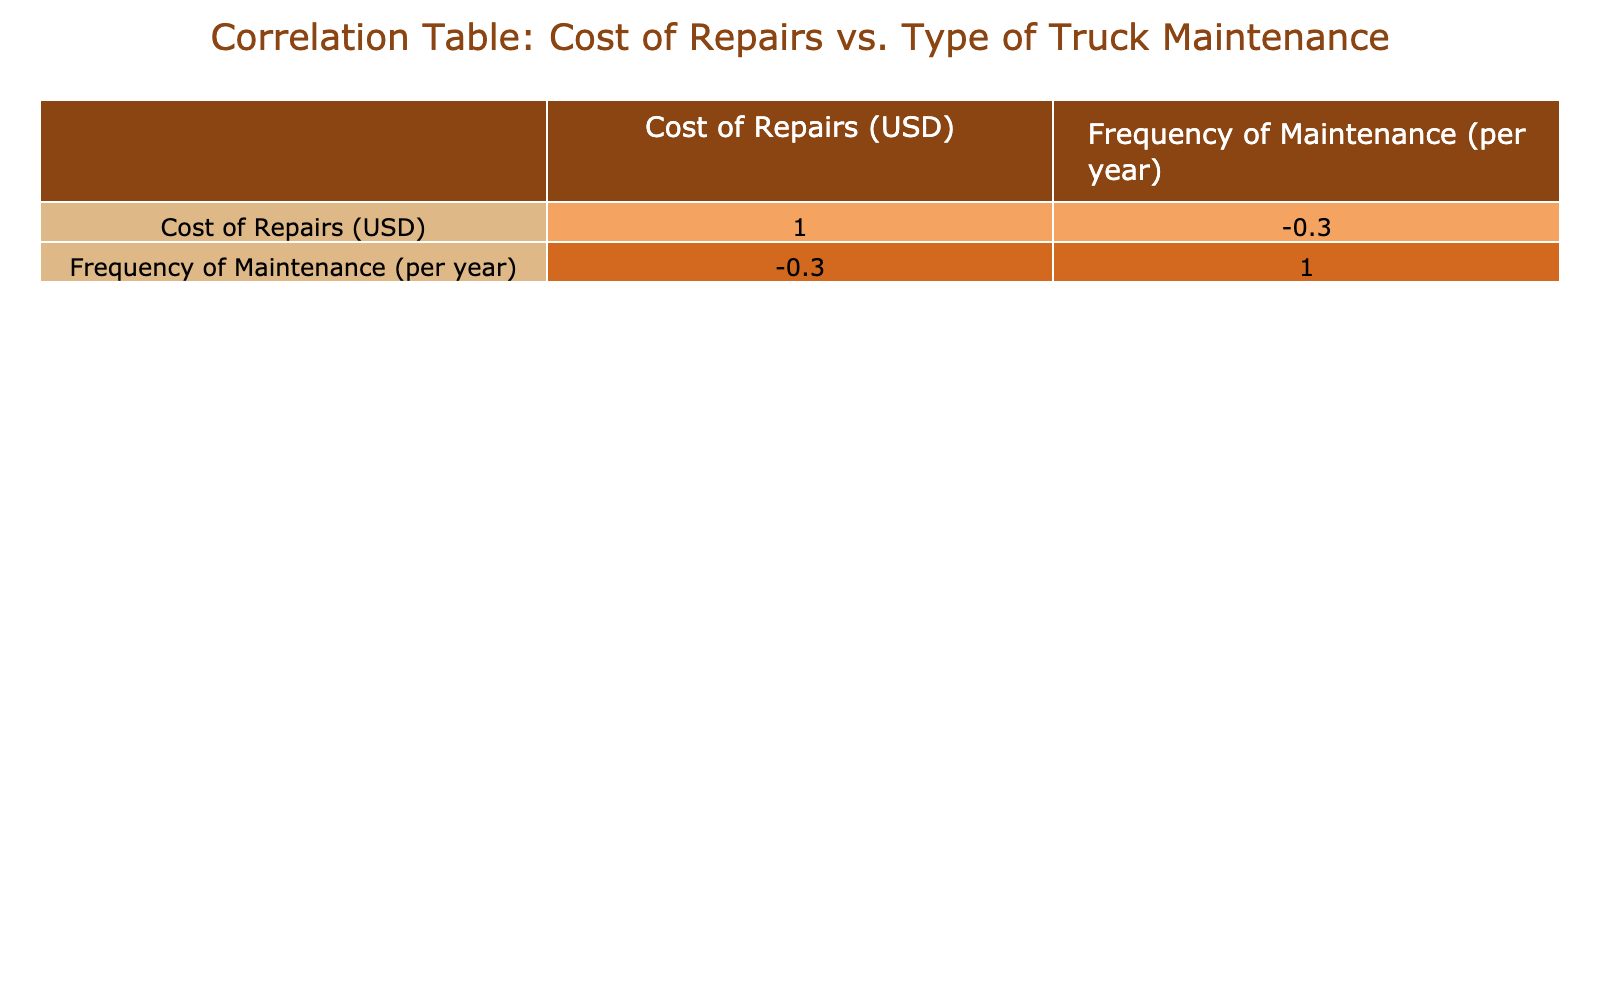What is the cost of an oil change? The table lists the cost under the "Cost of Repairs (USD)" column. For the oil change type of maintenance, the cost is specified as 100 USD.
Answer: 100 USD Which maintenance type has the highest cost of repairs? By inspecting the "Cost of Repairs (USD)" column, the maintenance type with the highest value is tire replacement at 800 USD.
Answer: Tire Replacement Is the frequency of maintenance for an engine tune-up more than once per year? The table indicates that the frequency of maintenance for an engine tune-up is 1 per year, which is not more than once.
Answer: No What is the average cost of repairs for maintenance types conducted once a year? For types conducted once a year, the costs are brake pad replacement (300), engine tune-up (500), transmission service (700), battery replacement (200), and coolant flush (150). The total cost is 300 + 500 + 700 + 200 + 150 = 1850, and there are 5 maintenance types. The average is 1850 / 5 = 370.
Answer: 370 USD How many maintenance types have a cost of repairs greater than 600 USD? The types with costs greater than 600 include tire replacement (800) and transmission service (700). There are 2 types that meet this criterion.
Answer: 2 types What is the total cost of all maintenance types listed in the table? To find the total cost, add together all costs: 100 + 800 + 300 + 500 + 700 + 150 + 200 + 400 + 250 + 150 = 3100 USD.
Answer: 3100 USD Which maintenance type has the lowest frequency of maintenance? The frequencies listed are as follows: oil change (4), tire replacement (2), brake pad replacement (1), engine tune-up (1), transmission service (1), fleet inspection (2), and battery replacement (1). Hence, brake pad replacement, engine tune-up, transmission service, and battery replacement each occur once, so any of these can be considered the lowest.
Answer: Brake Pad Replacement, Engine Tune-Up, Transmission Service, Battery Replacement If one were to perform all types of maintenance twice a year, what would be the total cost? First, we multiply the cost of each maintenance type by 2 since each would be performed twice: (100 + 800 + 300 + 500 + 700 + 150 + 200 + 400 + 250 + 150) * 2 = 6200 USD. Thus, the total cost is 6200 USD when performed twice yearly.
Answer: 6200 USD Are there more maintenance types with a frequency of 2 per year than those with a frequency of 1 per year? The maintenance types with a frequency of 2 are tire replacement, fleet inspection, and fuel system cleaning, totaling 3 types. The types with a frequency of 1 are brake pad replacement, engine tune-up, transmission service, battery replacement, and coolant flush, totaling 5 types. Therefore, there are not more types with a frequency of 2.
Answer: No 